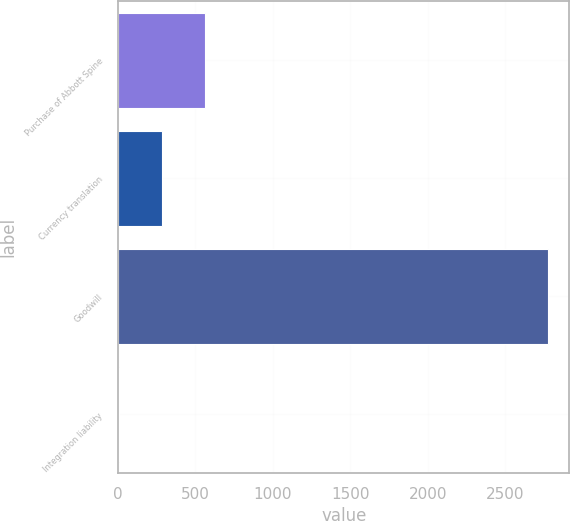Convert chart. <chart><loc_0><loc_0><loc_500><loc_500><bar_chart><fcel>Purchase of Abbott Spine<fcel>Currency translation<fcel>Goodwill<fcel>Integration liability<nl><fcel>559.36<fcel>282.43<fcel>2774.8<fcel>5.5<nl></chart> 